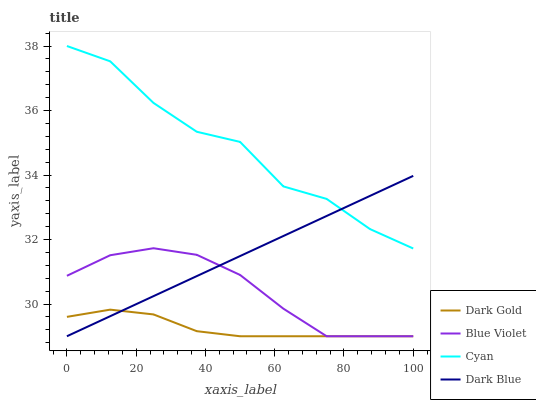Does Dark Blue have the minimum area under the curve?
Answer yes or no. No. Does Dark Blue have the maximum area under the curve?
Answer yes or no. No. Is Blue Violet the smoothest?
Answer yes or no. No. Is Blue Violet the roughest?
Answer yes or no. No. Does Dark Blue have the highest value?
Answer yes or no. No. Is Dark Gold less than Cyan?
Answer yes or no. Yes. Is Cyan greater than Blue Violet?
Answer yes or no. Yes. Does Dark Gold intersect Cyan?
Answer yes or no. No. 